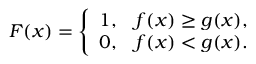Convert formula to latex. <formula><loc_0><loc_0><loc_500><loc_500>\begin{array} { r } { F ( x ) = \left \{ \begin{array} { l l } { 1 , } & { f ( x ) \geq g ( x ) , } \\ { 0 , } & { f ( x ) < g ( x ) . } \end{array} } \end{array}</formula> 